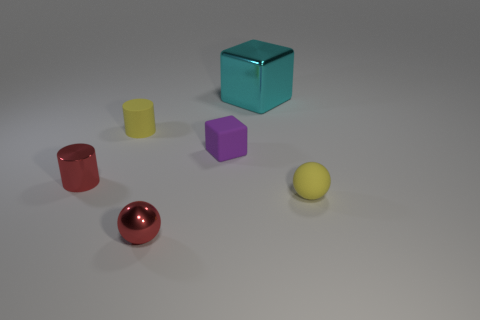Add 2 small yellow cylinders. How many objects exist? 8 Subtract all cylinders. How many objects are left? 4 Add 3 small objects. How many small objects exist? 8 Subtract 1 cyan blocks. How many objects are left? 5 Subtract all large cyan metallic things. Subtract all cyan metal things. How many objects are left? 4 Add 5 small yellow balls. How many small yellow balls are left? 6 